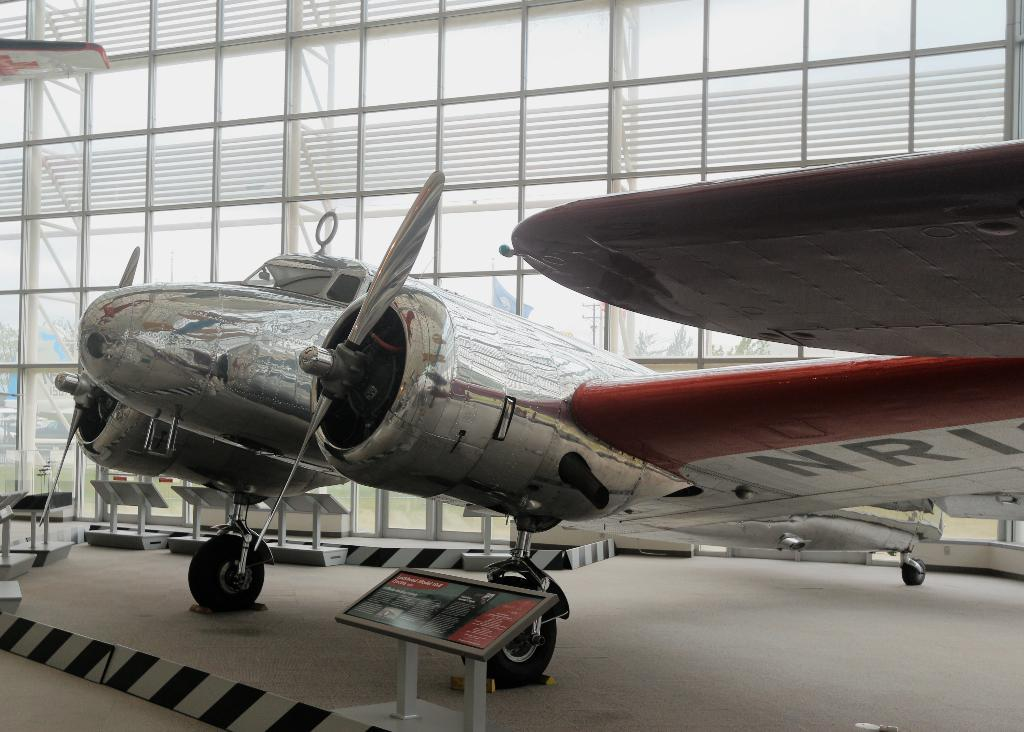Provide a one-sentence caption for the provided image. A sliver chrome airplane inside a building with the letters NRI cut off on a wing. 